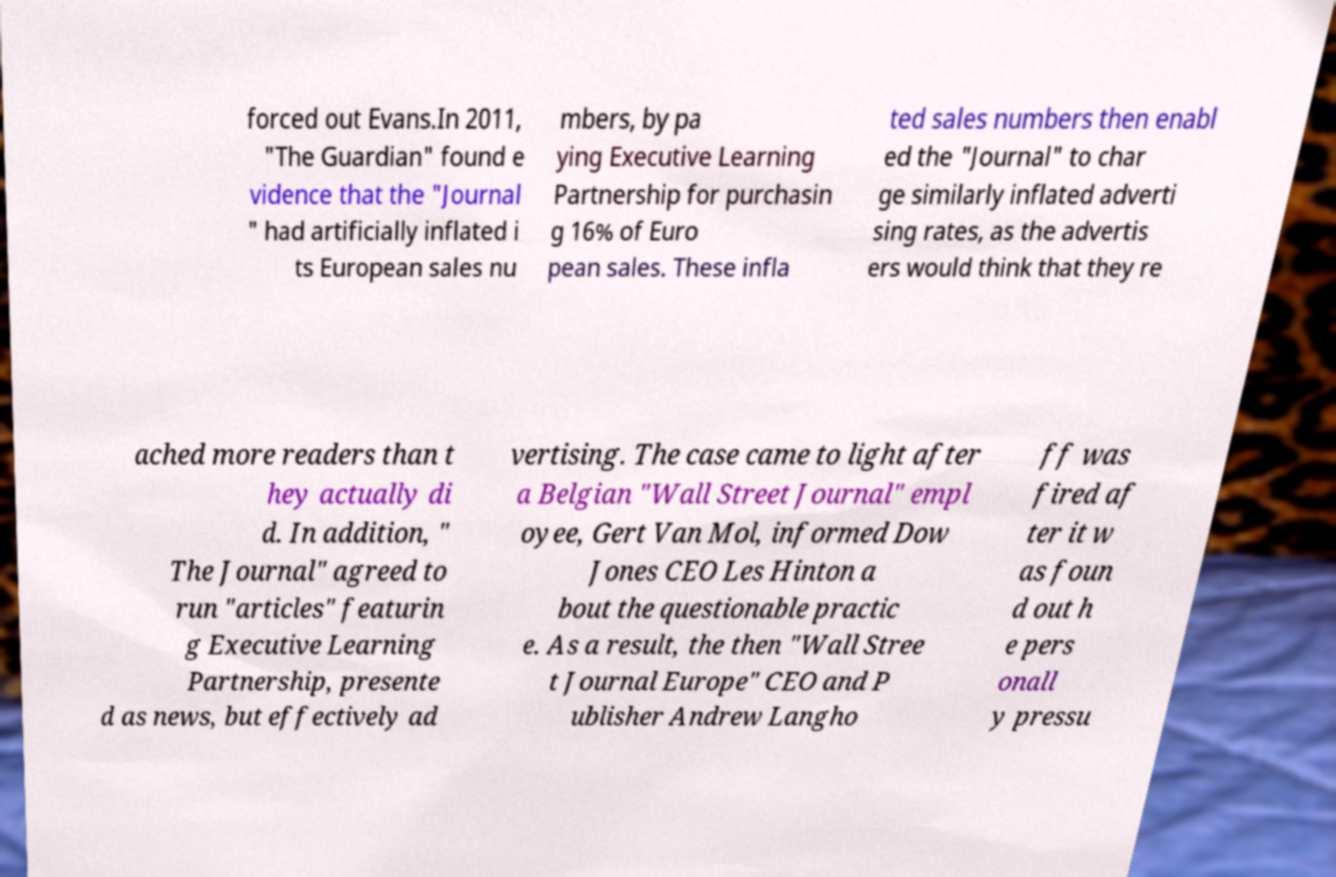Can you accurately transcribe the text from the provided image for me? forced out Evans.In 2011, "The Guardian" found e vidence that the "Journal " had artificially inflated i ts European sales nu mbers, by pa ying Executive Learning Partnership for purchasin g 16% of Euro pean sales. These infla ted sales numbers then enabl ed the "Journal" to char ge similarly inflated adverti sing rates, as the advertis ers would think that they re ached more readers than t hey actually di d. In addition, " The Journal" agreed to run "articles" featurin g Executive Learning Partnership, presente d as news, but effectively ad vertising. The case came to light after a Belgian "Wall Street Journal" empl oyee, Gert Van Mol, informed Dow Jones CEO Les Hinton a bout the questionable practic e. As a result, the then "Wall Stree t Journal Europe" CEO and P ublisher Andrew Langho ff was fired af ter it w as foun d out h e pers onall y pressu 